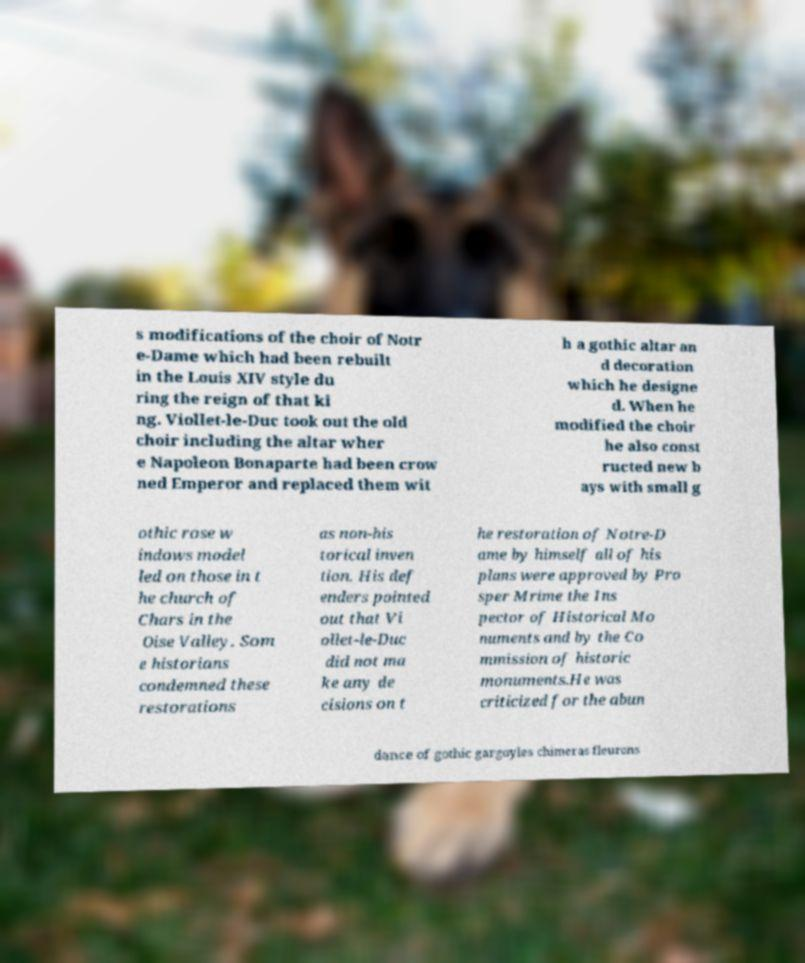For documentation purposes, I need the text within this image transcribed. Could you provide that? s modifications of the choir of Notr e-Dame which had been rebuilt in the Louis XIV style du ring the reign of that ki ng. Viollet-le-Duc took out the old choir including the altar wher e Napoleon Bonaparte had been crow ned Emperor and replaced them wit h a gothic altar an d decoration which he designe d. When he modified the choir he also const ructed new b ays with small g othic rose w indows model led on those in t he church of Chars in the Oise Valley. Som e historians condemned these restorations as non-his torical inven tion. His def enders pointed out that Vi ollet-le-Duc did not ma ke any de cisions on t he restoration of Notre-D ame by himself all of his plans were approved by Pro sper Mrime the Ins pector of Historical Mo numents and by the Co mmission of historic monuments.He was criticized for the abun dance of gothic gargoyles chimeras fleurons 